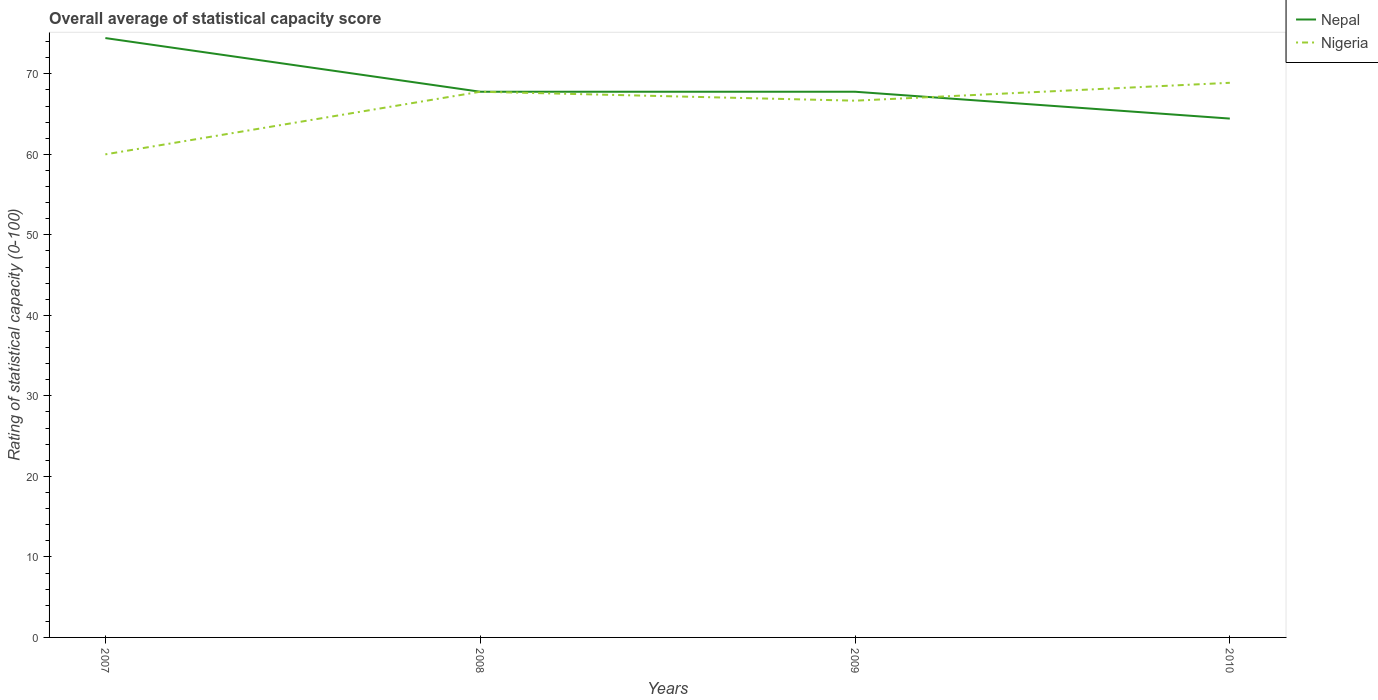How many different coloured lines are there?
Give a very brief answer. 2. Is the number of lines equal to the number of legend labels?
Give a very brief answer. Yes. Across all years, what is the maximum rating of statistical capacity in Nepal?
Provide a short and direct response. 64.44. In which year was the rating of statistical capacity in Nepal maximum?
Provide a succinct answer. 2010. What is the total rating of statistical capacity in Nigeria in the graph?
Offer a very short reply. -1.11. What is the difference between the highest and the second highest rating of statistical capacity in Nigeria?
Your response must be concise. 8.89. What is the difference between the highest and the lowest rating of statistical capacity in Nigeria?
Your response must be concise. 3. Is the rating of statistical capacity in Nepal strictly greater than the rating of statistical capacity in Nigeria over the years?
Make the answer very short. No. Does the graph contain any zero values?
Your answer should be very brief. No. Does the graph contain grids?
Your response must be concise. No. What is the title of the graph?
Offer a very short reply. Overall average of statistical capacity score. What is the label or title of the Y-axis?
Your answer should be compact. Rating of statistical capacity (0-100). What is the Rating of statistical capacity (0-100) of Nepal in 2007?
Give a very brief answer. 74.44. What is the Rating of statistical capacity (0-100) of Nigeria in 2007?
Your response must be concise. 60. What is the Rating of statistical capacity (0-100) in Nepal in 2008?
Make the answer very short. 67.78. What is the Rating of statistical capacity (0-100) in Nigeria in 2008?
Ensure brevity in your answer.  67.78. What is the Rating of statistical capacity (0-100) in Nepal in 2009?
Ensure brevity in your answer.  67.78. What is the Rating of statistical capacity (0-100) of Nigeria in 2009?
Your answer should be compact. 66.67. What is the Rating of statistical capacity (0-100) of Nepal in 2010?
Your response must be concise. 64.44. What is the Rating of statistical capacity (0-100) of Nigeria in 2010?
Your answer should be compact. 68.89. Across all years, what is the maximum Rating of statistical capacity (0-100) of Nepal?
Make the answer very short. 74.44. Across all years, what is the maximum Rating of statistical capacity (0-100) of Nigeria?
Provide a succinct answer. 68.89. Across all years, what is the minimum Rating of statistical capacity (0-100) in Nepal?
Your response must be concise. 64.44. What is the total Rating of statistical capacity (0-100) of Nepal in the graph?
Provide a short and direct response. 274.44. What is the total Rating of statistical capacity (0-100) in Nigeria in the graph?
Make the answer very short. 263.33. What is the difference between the Rating of statistical capacity (0-100) in Nepal in 2007 and that in 2008?
Your answer should be very brief. 6.67. What is the difference between the Rating of statistical capacity (0-100) in Nigeria in 2007 and that in 2008?
Provide a succinct answer. -7.78. What is the difference between the Rating of statistical capacity (0-100) of Nepal in 2007 and that in 2009?
Your answer should be very brief. 6.67. What is the difference between the Rating of statistical capacity (0-100) in Nigeria in 2007 and that in 2009?
Your answer should be very brief. -6.67. What is the difference between the Rating of statistical capacity (0-100) of Nepal in 2007 and that in 2010?
Your response must be concise. 10. What is the difference between the Rating of statistical capacity (0-100) in Nigeria in 2007 and that in 2010?
Offer a terse response. -8.89. What is the difference between the Rating of statistical capacity (0-100) in Nigeria in 2008 and that in 2009?
Keep it short and to the point. 1.11. What is the difference between the Rating of statistical capacity (0-100) of Nigeria in 2008 and that in 2010?
Ensure brevity in your answer.  -1.11. What is the difference between the Rating of statistical capacity (0-100) in Nigeria in 2009 and that in 2010?
Offer a terse response. -2.22. What is the difference between the Rating of statistical capacity (0-100) in Nepal in 2007 and the Rating of statistical capacity (0-100) in Nigeria in 2009?
Ensure brevity in your answer.  7.78. What is the difference between the Rating of statistical capacity (0-100) in Nepal in 2007 and the Rating of statistical capacity (0-100) in Nigeria in 2010?
Give a very brief answer. 5.56. What is the difference between the Rating of statistical capacity (0-100) of Nepal in 2008 and the Rating of statistical capacity (0-100) of Nigeria in 2009?
Your answer should be very brief. 1.11. What is the difference between the Rating of statistical capacity (0-100) of Nepal in 2008 and the Rating of statistical capacity (0-100) of Nigeria in 2010?
Make the answer very short. -1.11. What is the difference between the Rating of statistical capacity (0-100) of Nepal in 2009 and the Rating of statistical capacity (0-100) of Nigeria in 2010?
Offer a very short reply. -1.11. What is the average Rating of statistical capacity (0-100) in Nepal per year?
Make the answer very short. 68.61. What is the average Rating of statistical capacity (0-100) in Nigeria per year?
Provide a succinct answer. 65.83. In the year 2007, what is the difference between the Rating of statistical capacity (0-100) in Nepal and Rating of statistical capacity (0-100) in Nigeria?
Your response must be concise. 14.44. In the year 2008, what is the difference between the Rating of statistical capacity (0-100) of Nepal and Rating of statistical capacity (0-100) of Nigeria?
Provide a short and direct response. 0. In the year 2009, what is the difference between the Rating of statistical capacity (0-100) in Nepal and Rating of statistical capacity (0-100) in Nigeria?
Offer a very short reply. 1.11. In the year 2010, what is the difference between the Rating of statistical capacity (0-100) of Nepal and Rating of statistical capacity (0-100) of Nigeria?
Provide a succinct answer. -4.44. What is the ratio of the Rating of statistical capacity (0-100) in Nepal in 2007 to that in 2008?
Offer a very short reply. 1.1. What is the ratio of the Rating of statistical capacity (0-100) of Nigeria in 2007 to that in 2008?
Offer a terse response. 0.89. What is the ratio of the Rating of statistical capacity (0-100) in Nepal in 2007 to that in 2009?
Provide a short and direct response. 1.1. What is the ratio of the Rating of statistical capacity (0-100) in Nepal in 2007 to that in 2010?
Provide a short and direct response. 1.16. What is the ratio of the Rating of statistical capacity (0-100) in Nigeria in 2007 to that in 2010?
Your answer should be very brief. 0.87. What is the ratio of the Rating of statistical capacity (0-100) of Nigeria in 2008 to that in 2009?
Offer a terse response. 1.02. What is the ratio of the Rating of statistical capacity (0-100) in Nepal in 2008 to that in 2010?
Give a very brief answer. 1.05. What is the ratio of the Rating of statistical capacity (0-100) in Nigeria in 2008 to that in 2010?
Offer a terse response. 0.98. What is the ratio of the Rating of statistical capacity (0-100) in Nepal in 2009 to that in 2010?
Make the answer very short. 1.05. What is the difference between the highest and the second highest Rating of statistical capacity (0-100) of Nepal?
Offer a very short reply. 6.67. What is the difference between the highest and the second highest Rating of statistical capacity (0-100) in Nigeria?
Your response must be concise. 1.11. What is the difference between the highest and the lowest Rating of statistical capacity (0-100) of Nigeria?
Offer a terse response. 8.89. 